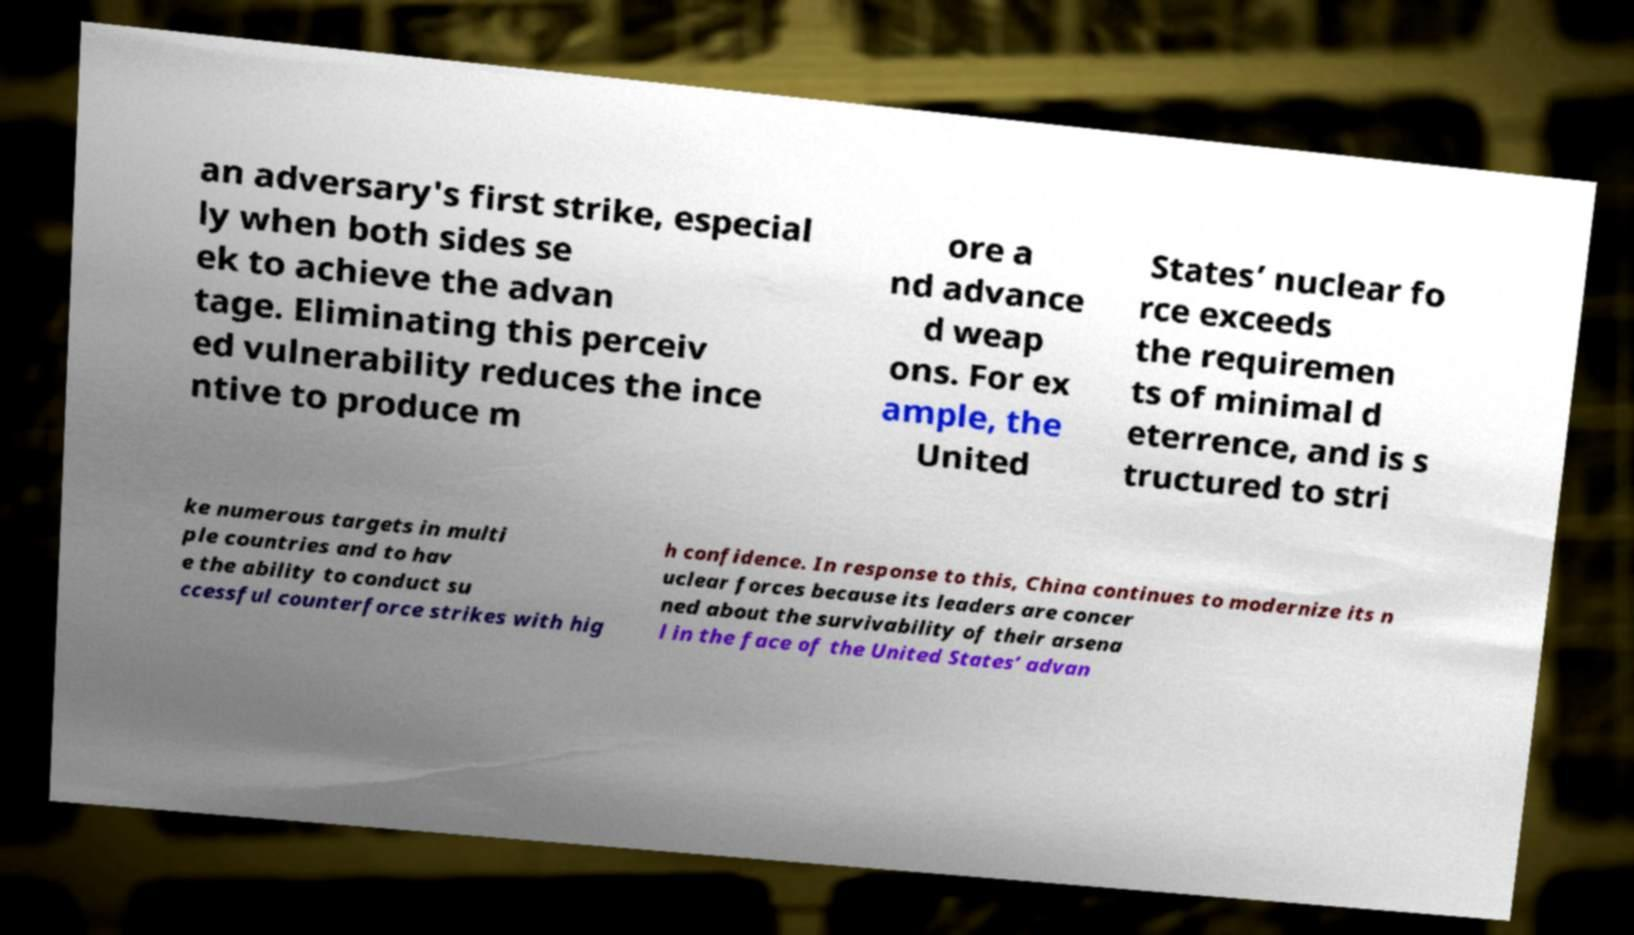Please identify and transcribe the text found in this image. an adversary's first strike, especial ly when both sides se ek to achieve the advan tage. Eliminating this perceiv ed vulnerability reduces the ince ntive to produce m ore a nd advance d weap ons. For ex ample, the United States’ nuclear fo rce exceeds the requiremen ts of minimal d eterrence, and is s tructured to stri ke numerous targets in multi ple countries and to hav e the ability to conduct su ccessful counterforce strikes with hig h confidence. In response to this, China continues to modernize its n uclear forces because its leaders are concer ned about the survivability of their arsena l in the face of the United States’ advan 